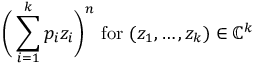Convert formula to latex. <formula><loc_0><loc_0><loc_500><loc_500>{ \left ( } \sum _ { i = 1 } ^ { k } p _ { i } z _ { i } { \right ) } ^ { n } { f o r } ( z _ { 1 } , \dots , z _ { k } ) \in \mathbb { C } ^ { k }</formula> 